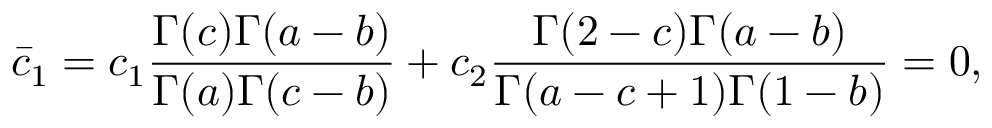<formula> <loc_0><loc_0><loc_500><loc_500>\bar { c } _ { 1 } = c _ { 1 } \frac { \Gamma ( c ) \Gamma ( a - b ) } { \Gamma ( a ) \Gamma ( c - b ) } + c _ { 2 } \frac { \Gamma ( 2 - c ) \Gamma ( a - b ) } { \Gamma ( a - c + 1 ) \Gamma ( 1 - b ) } = 0 ,</formula> 